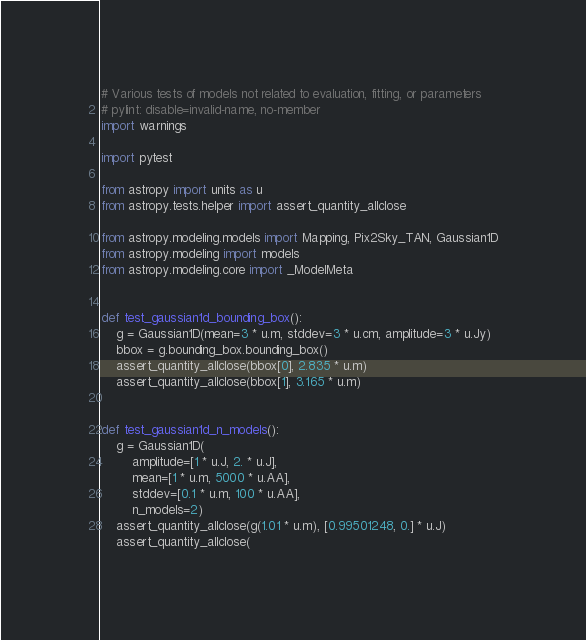<code> <loc_0><loc_0><loc_500><loc_500><_Python_># Various tests of models not related to evaluation, fitting, or parameters
# pylint: disable=invalid-name, no-member
import warnings

import pytest

from astropy import units as u
from astropy.tests.helper import assert_quantity_allclose

from astropy.modeling.models import Mapping, Pix2Sky_TAN, Gaussian1D
from astropy.modeling import models
from astropy.modeling.core import _ModelMeta


def test_gaussian1d_bounding_box():
    g = Gaussian1D(mean=3 * u.m, stddev=3 * u.cm, amplitude=3 * u.Jy)
    bbox = g.bounding_box.bounding_box()
    assert_quantity_allclose(bbox[0], 2.835 * u.m)
    assert_quantity_allclose(bbox[1], 3.165 * u.m)


def test_gaussian1d_n_models():
    g = Gaussian1D(
        amplitude=[1 * u.J, 2. * u.J],
        mean=[1 * u.m, 5000 * u.AA],
        stddev=[0.1 * u.m, 100 * u.AA],
        n_models=2)
    assert_quantity_allclose(g(1.01 * u.m), [0.99501248, 0.] * u.J)
    assert_quantity_allclose(</code> 